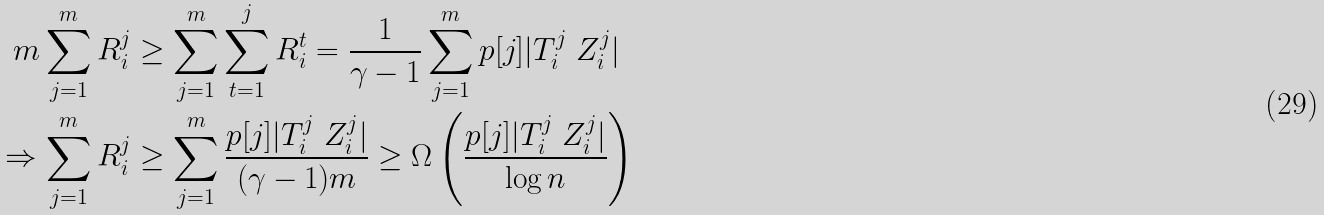Convert formula to latex. <formula><loc_0><loc_0><loc_500><loc_500>m \sum _ { j = 1 } ^ { m } R _ { i } ^ { j } & \geq \sum _ { j = 1 } ^ { m } \sum _ { t = 1 } ^ { j } R _ { i } ^ { t } = \frac { 1 } { \gamma - 1 } \sum _ { j = 1 } ^ { m } p [ j ] | T _ { i } ^ { j } \ Z _ { i } ^ { j } | \\ \Rightarrow \sum _ { j = 1 } ^ { m } R _ { i } ^ { j } & \geq \sum _ { j = 1 } ^ { m } \frac { p [ j ] | T _ { i } ^ { j } \ Z _ { i } ^ { j } | } { ( \gamma - 1 ) m } \geq \Omega \left ( \frac { p [ j ] | T _ { i } ^ { j } \ Z _ { i } ^ { j } | } { \log n } \right ) \\</formula> 